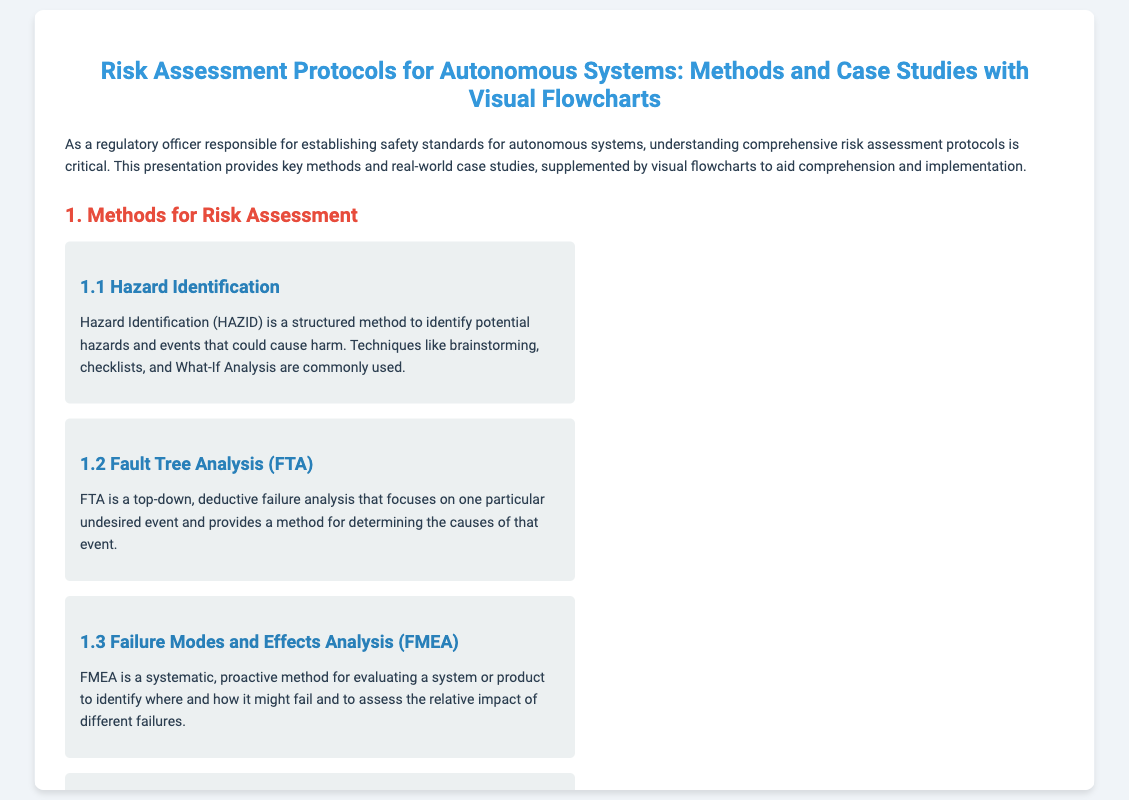what is the title of the presentation? The title of the presentation is stated at the top of the document.
Answer: Risk Assessment Protocols for Autonomous Systems: Methods and Case Studies with Visual Flowcharts what is the first method for risk assessment listed? The first method for risk assessment is given in the section under 'Methods for Risk Assessment'.
Answer: Hazard Identification what does FMEA stand for? The acronym FMEA is mentioned in the context of risk assessment methods.
Answer: Failure Modes and Effects Analysis which organization developed the Federal Automated Vehicles Policy? The organization responsible for the policy is named in the case studies section.
Answer: National Highway Traffic Safety Administration how many case studies are presented? The number of case studies can be counted in the relevant section.
Answer: Three what is the flowchart's primary purpose mentioned in the presentation? The purpose of flowcharts is described in the section about visual flowcharts.
Answer: Aiding in understanding and application what safety standard is referenced for industrial robotics? The specific safety standard for industrial robotics is mentioned under the case studies section.
Answer: ISO 10218 and ANSI/RIA R15.06 what does PRA stand for? The text refers to PRA in the context of risk assessment methods.
Answer: Probabilistic Risk Assessment what is the concluding statement about implementing risk assessment protocols? The conclusion provides insight into the benefits of adopting these protocols.
Answer: Enhance the safety of autonomous systems 